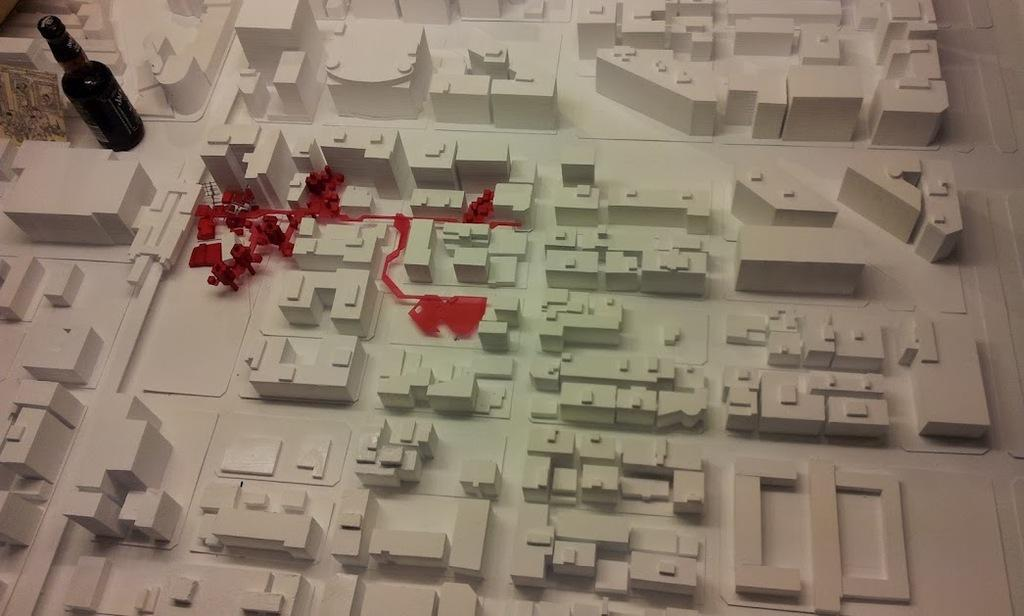What type of objects are present in the image that are white in color? There are white blocks in the image. What is the color of the cloth visible in the image? There is a red cloth in the image. Are there any patterns or designs in the image? Yes, there are markings in the image. What type of beverage container can be seen in the image? There is a wine bottle in the image. Can you see a snail crawling on the red cloth in the image? No, there is no snail present in the image. Is there a party happening in the image? The image does not depict a party or any party-related activities. 